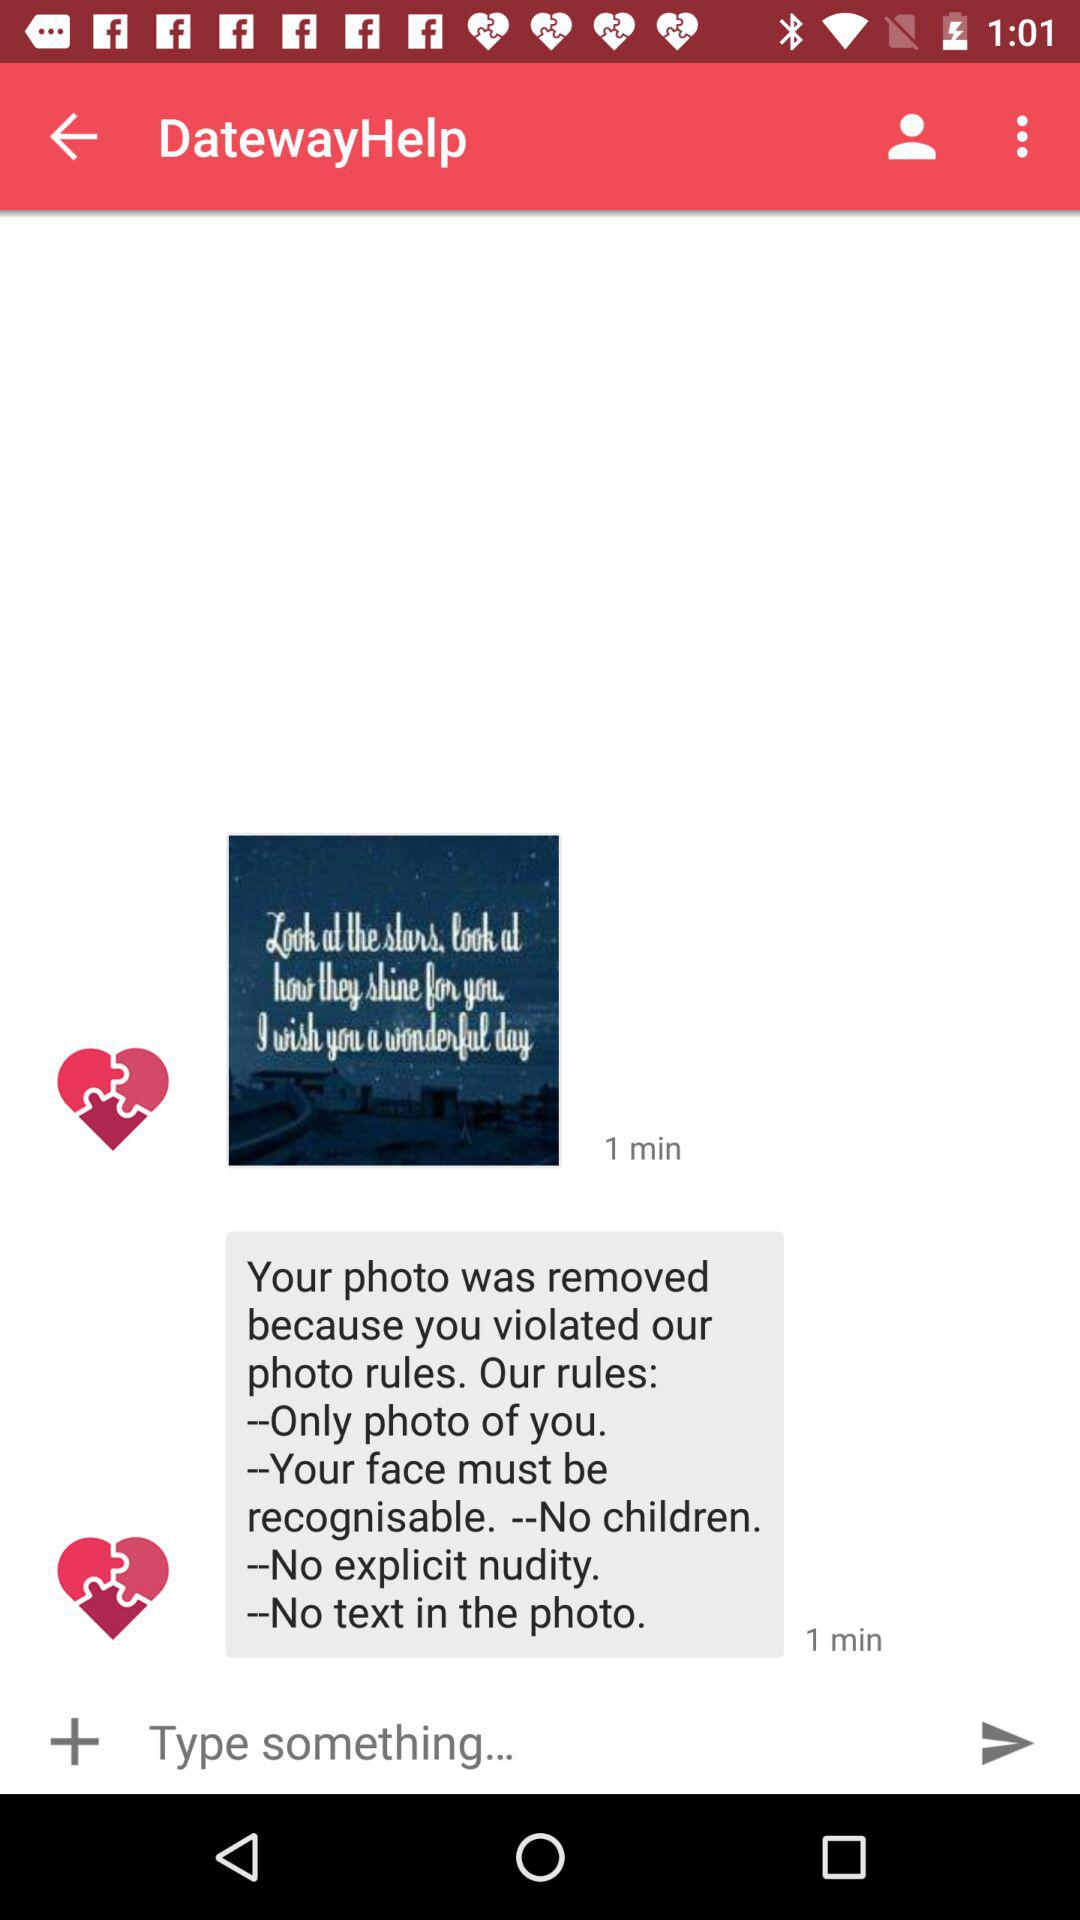How many minutes the message has been received?
When the provided information is insufficient, respond with <no answer>. <no answer> 